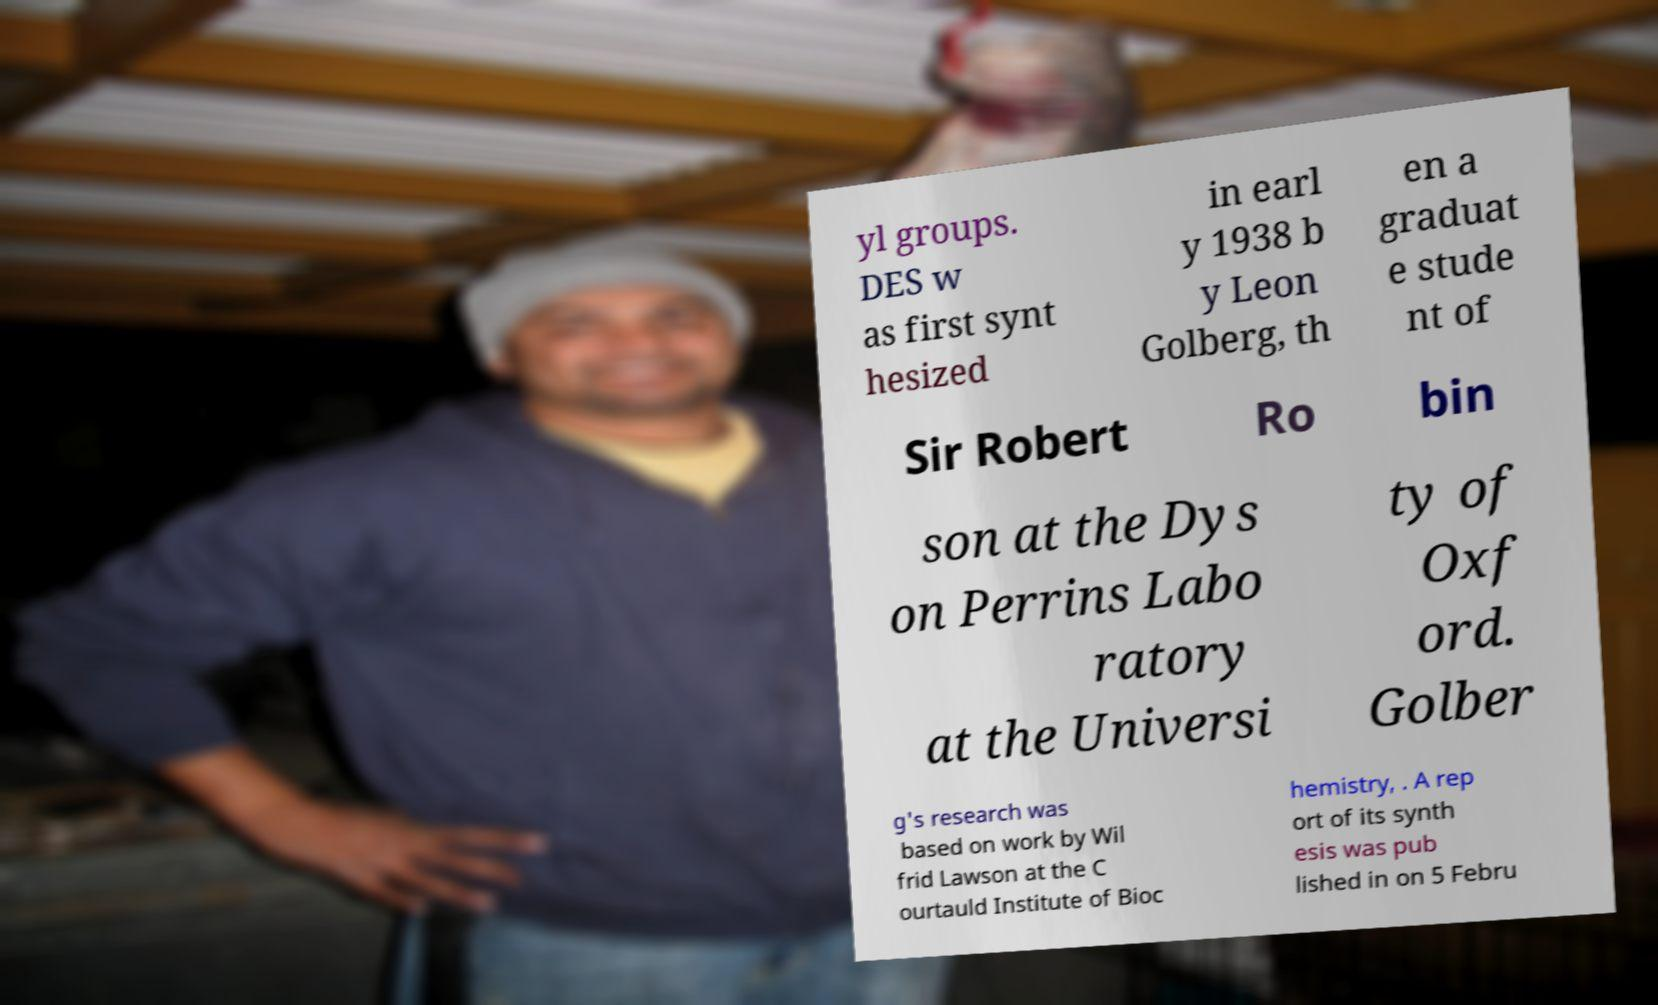I need the written content from this picture converted into text. Can you do that? yl groups. DES w as first synt hesized in earl y 1938 b y Leon Golberg, th en a graduat e stude nt of Sir Robert Ro bin son at the Dys on Perrins Labo ratory at the Universi ty of Oxf ord. Golber g's research was based on work by Wil frid Lawson at the C ourtauld Institute of Bioc hemistry, . A rep ort of its synth esis was pub lished in on 5 Febru 